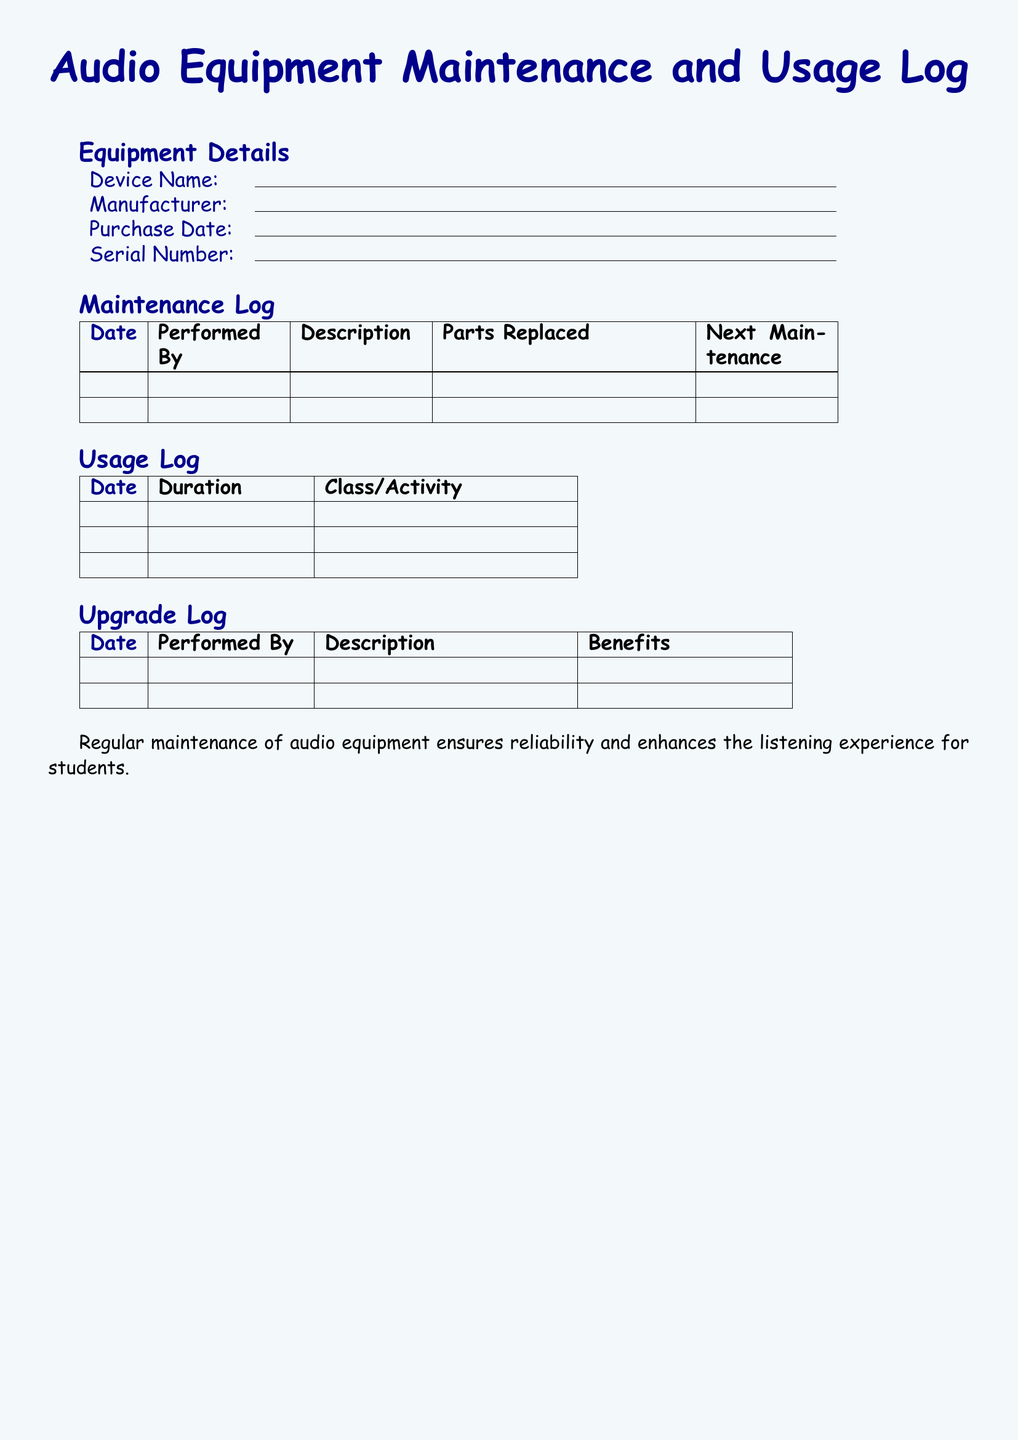What is the title of the document? The title of the document is prominently displayed at the top, which is "Audio Equipment Maintenance and Usage Log."
Answer: Audio Equipment Maintenance and Usage Log What is the main color theme used in the document? The main color theme is represented by the background and text color, highlighting light blue and dark blue.
Answer: Light blue and dark blue What sections are included in the Equipment Maintenance log? The document includes three main log sections: Maintenance Log, Usage Log, and Upgrade Log.
Answer: Maintenance Log, Usage Log, Upgrade Log What information can be found in the Equipment Details section? The Equipment Details section requires filling out device name, manufacturer, purchase date, and serial number.
Answer: Device Name, Manufacturer, Purchase Date, Serial Number How many columns are in the Maintenance Log table? The Maintenance Log table consists of five columns for date, performed by, description, parts replaced, and next maintenance.
Answer: Five columns Which log would you check for the duration of usage? The Usage Log is where you would look for the duration of usage for the audio equipment.
Answer: Usage Log What type of information is recorded in the Upgrade Log? The Upgrade Log captures details about the date, who performed the upgrade, the description, and the benefits of the upgrade.
Answer: Date, Performed By, Description, Benefits Why is regular maintenance emphasized in the document? The concluding statement indicates that regular maintenance ensures reliability and enhances the listening experience for students.
Answer: Reliability and enhancing listening experience What would you find in the "Parts Replaced" column of the Maintenance Log? The "Parts Replaced" column specifies any parts that were replaced during maintenance activities.
Answer: Parts replaced 